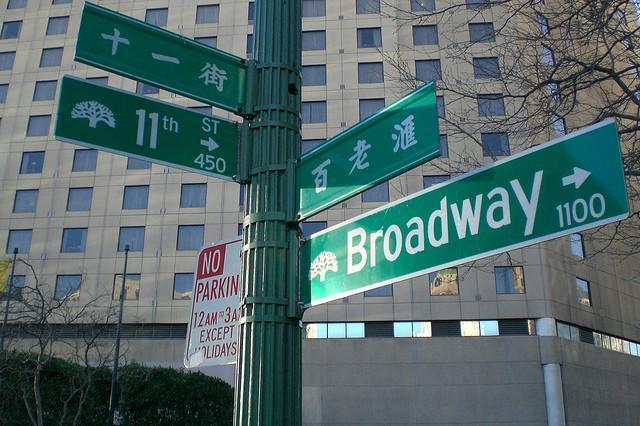How many signs are rectangular?
Give a very brief answer. 4. 